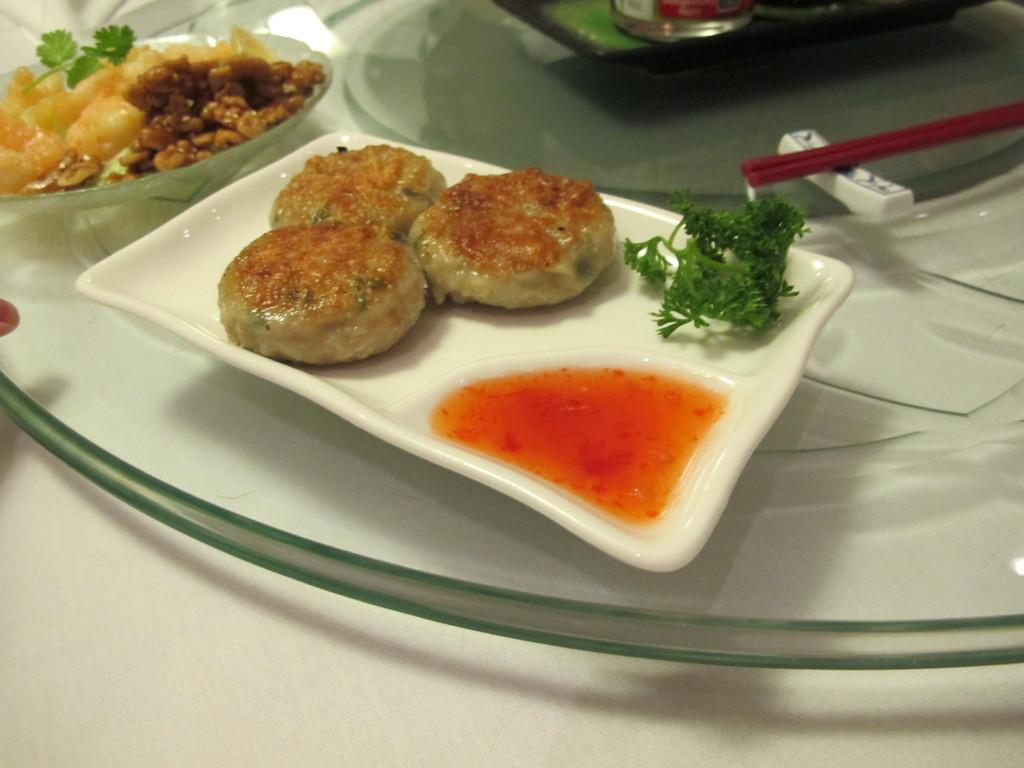What is present in the image related to food? There is food in the image. How is the food arranged or contained? The food is in a plate. Where is the plate with food located? The plate is placed on a table. What type of tree can be seen growing out of the pocket in the image? There is no tree or pocket present in the image. 